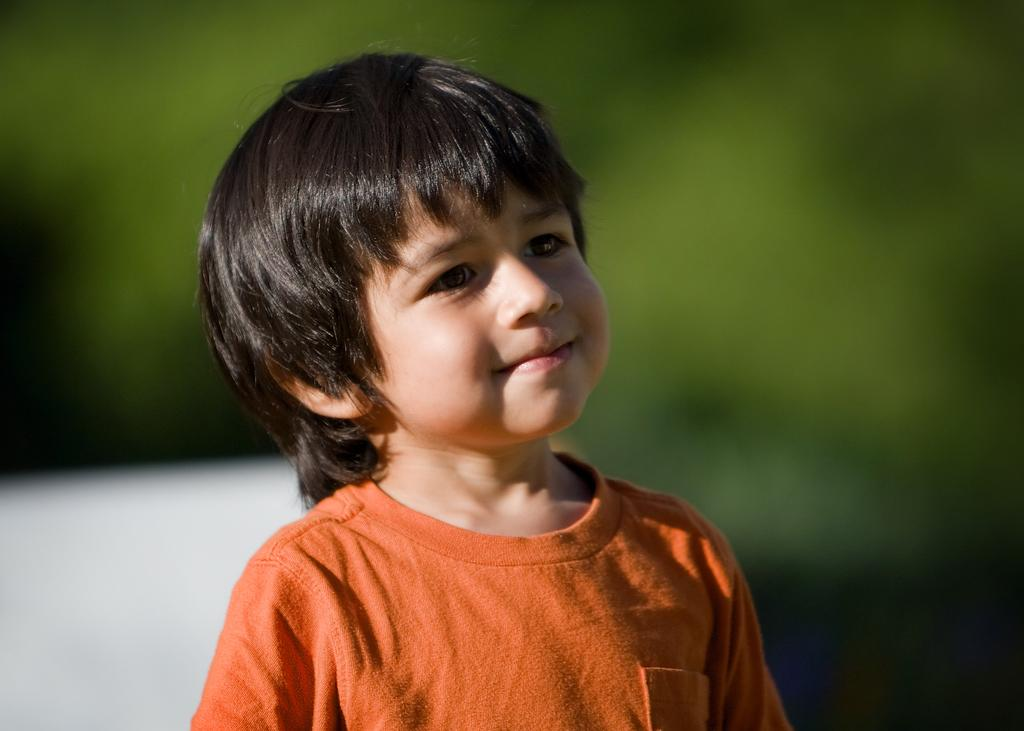What is the main subject of the image? The main subject of the image is a kid. What is the kid doing in the image? The kid is smiling in the image. What is the kid wearing in the image? The kid is wearing an orange t-shirt in the image. Can you describe the background of the image? The background of the image has a blurred view. What colors can be seen in the image? Green and white colors are present in the image. Is the kid experiencing any pain in the image? There is no indication in the image that the kid is experiencing pain. Can you tell me how many straws are in the image? There are no straws present in the image. 